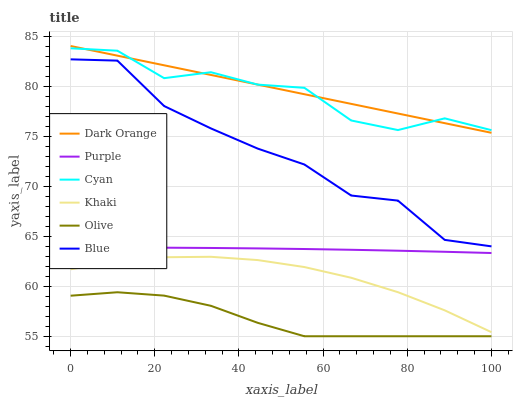Does Olive have the minimum area under the curve?
Answer yes or no. Yes. Does Dark Orange have the maximum area under the curve?
Answer yes or no. Yes. Does Khaki have the minimum area under the curve?
Answer yes or no. No. Does Khaki have the maximum area under the curve?
Answer yes or no. No. Is Dark Orange the smoothest?
Answer yes or no. Yes. Is Cyan the roughest?
Answer yes or no. Yes. Is Khaki the smoothest?
Answer yes or no. No. Is Khaki the roughest?
Answer yes or no. No. Does Olive have the lowest value?
Answer yes or no. Yes. Does Dark Orange have the lowest value?
Answer yes or no. No. Does Dark Orange have the highest value?
Answer yes or no. Yes. Does Khaki have the highest value?
Answer yes or no. No. Is Khaki less than Dark Orange?
Answer yes or no. Yes. Is Cyan greater than Blue?
Answer yes or no. Yes. Does Dark Orange intersect Cyan?
Answer yes or no. Yes. Is Dark Orange less than Cyan?
Answer yes or no. No. Is Dark Orange greater than Cyan?
Answer yes or no. No. Does Khaki intersect Dark Orange?
Answer yes or no. No. 